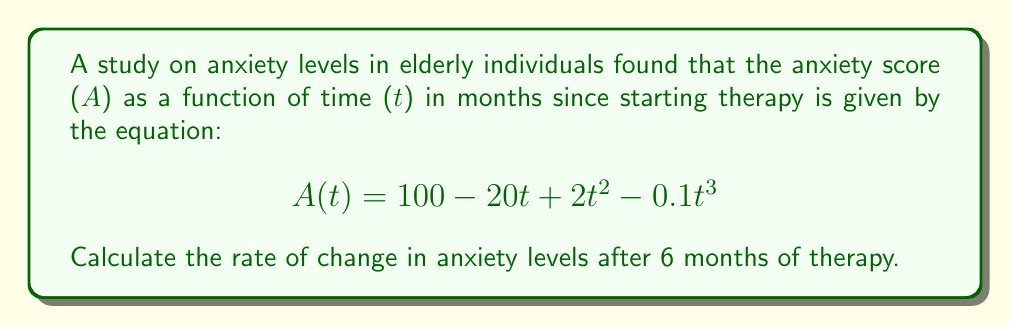What is the answer to this math problem? To find the rate of change in anxiety levels, we need to calculate the derivative of the given function A(t) with respect to t, and then evaluate it at t = 6.

Step 1: Find the derivative of A(t)
$$\frac{d}{dt}A(t) = \frac{d}{dt}(100 - 20t + 2t^2 - 0.1t^3)$$
$$A'(t) = 0 - 20 + 4t - 0.3t^2$$

Step 2: Simplify the derivative
$$A'(t) = -20 + 4t - 0.3t^2$$

Step 3: Evaluate the derivative at t = 6
$$A'(6) = -20 + 4(6) - 0.3(6)^2$$
$$A'(6) = -20 + 24 - 0.3(36)$$
$$A'(6) = -20 + 24 - 10.8$$
$$A'(6) = -6.8$$

The negative value indicates that anxiety levels are decreasing at this point in time.
Answer: $-6.8$ units per month 